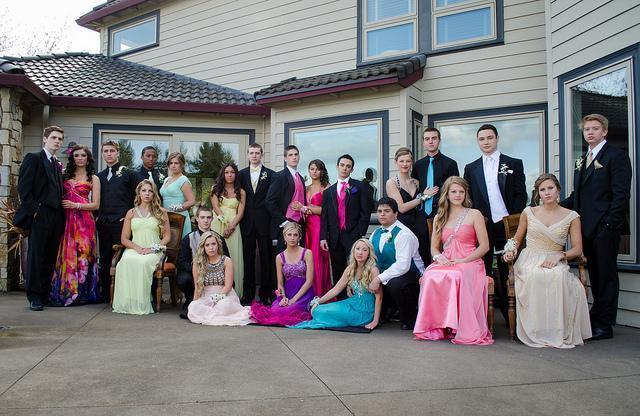How many people have on dresses?
Give a very brief answer. 11. How many people are there?
Give a very brief answer. 13. How many cars are driving in the opposite direction of the street car?
Give a very brief answer. 0. 